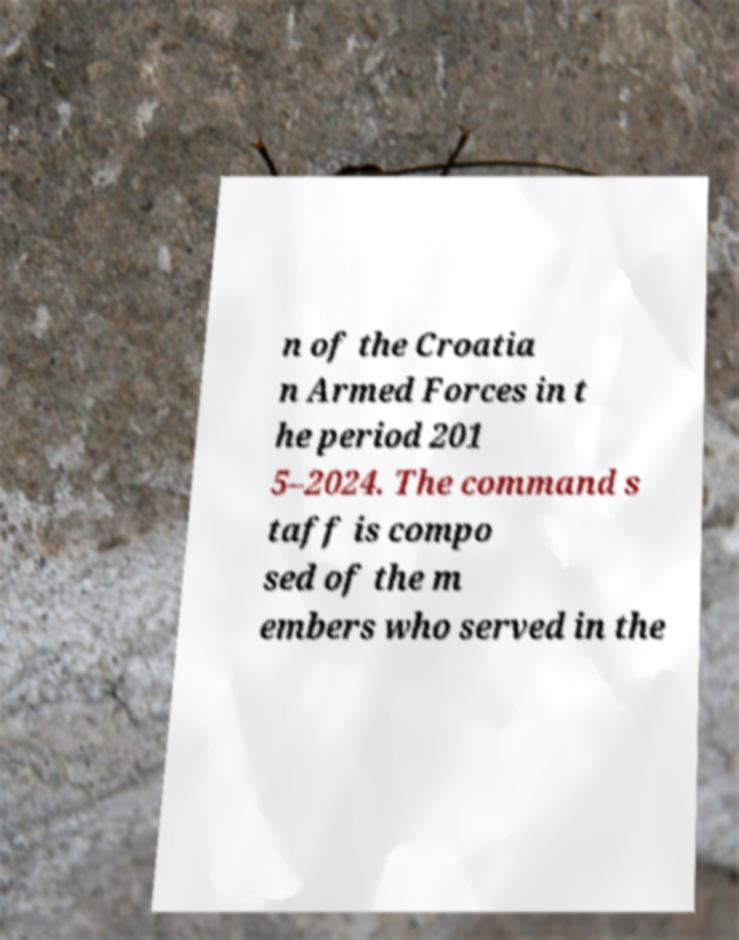Can you read and provide the text displayed in the image?This photo seems to have some interesting text. Can you extract and type it out for me? n of the Croatia n Armed Forces in t he period 201 5–2024. The command s taff is compo sed of the m embers who served in the 